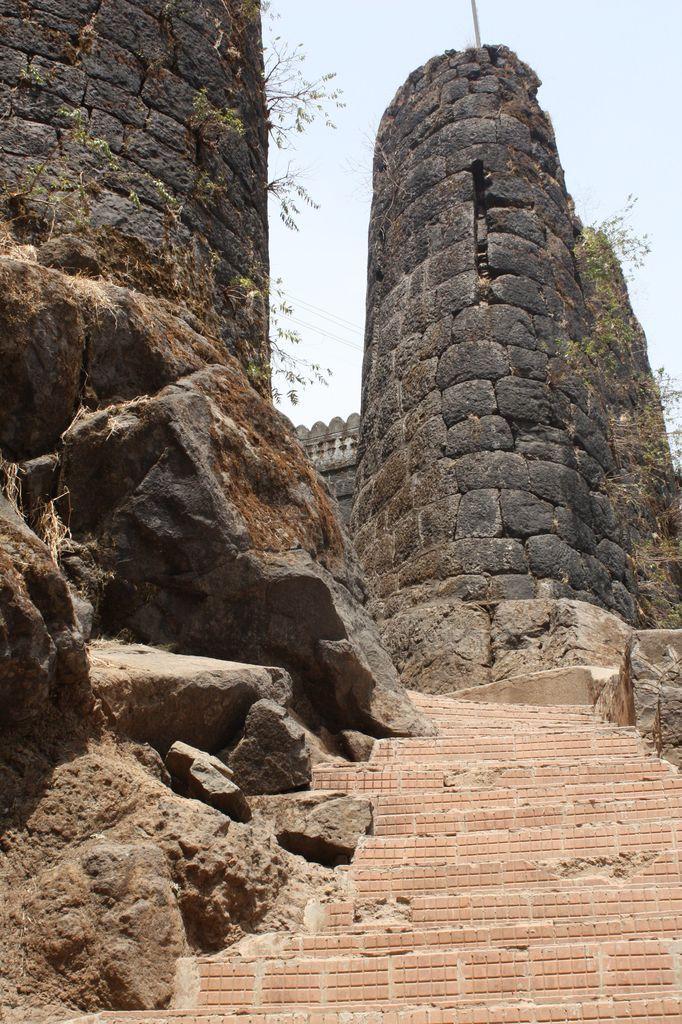In one or two sentences, can you explain what this image depicts? Here we can see stones at the steps. In the background there are big walls,plants,pole and sky. 